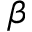Convert formula to latex. <formula><loc_0><loc_0><loc_500><loc_500>\beta</formula> 